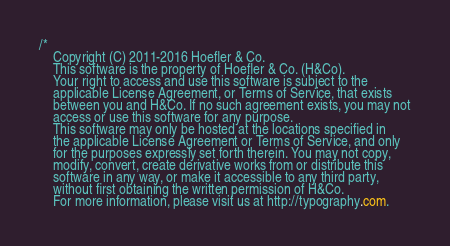Convert code to text. <code><loc_0><loc_0><loc_500><loc_500><_CSS_>
/*
	Copyright (C) 2011-2016 Hoefler & Co.
	This software is the property of Hoefler & Co. (H&Co).
	Your right to access and use this software is subject to the
	applicable License Agreement, or Terms of Service, that exists
	between you and H&Co. If no such agreement exists, you may not
	access or use this software for any purpose.
	This software may only be hosted at the locations specified in
	the applicable License Agreement or Terms of Service, and only
	for the purposes expressly set forth therein. You may not copy,
	modify, convert, create derivative works from or distribute this
	software in any way, or make it accessible to any third party,
	without first obtaining the written permission of H&Co.
	For more information, please visit us at http://typography.com.</code> 